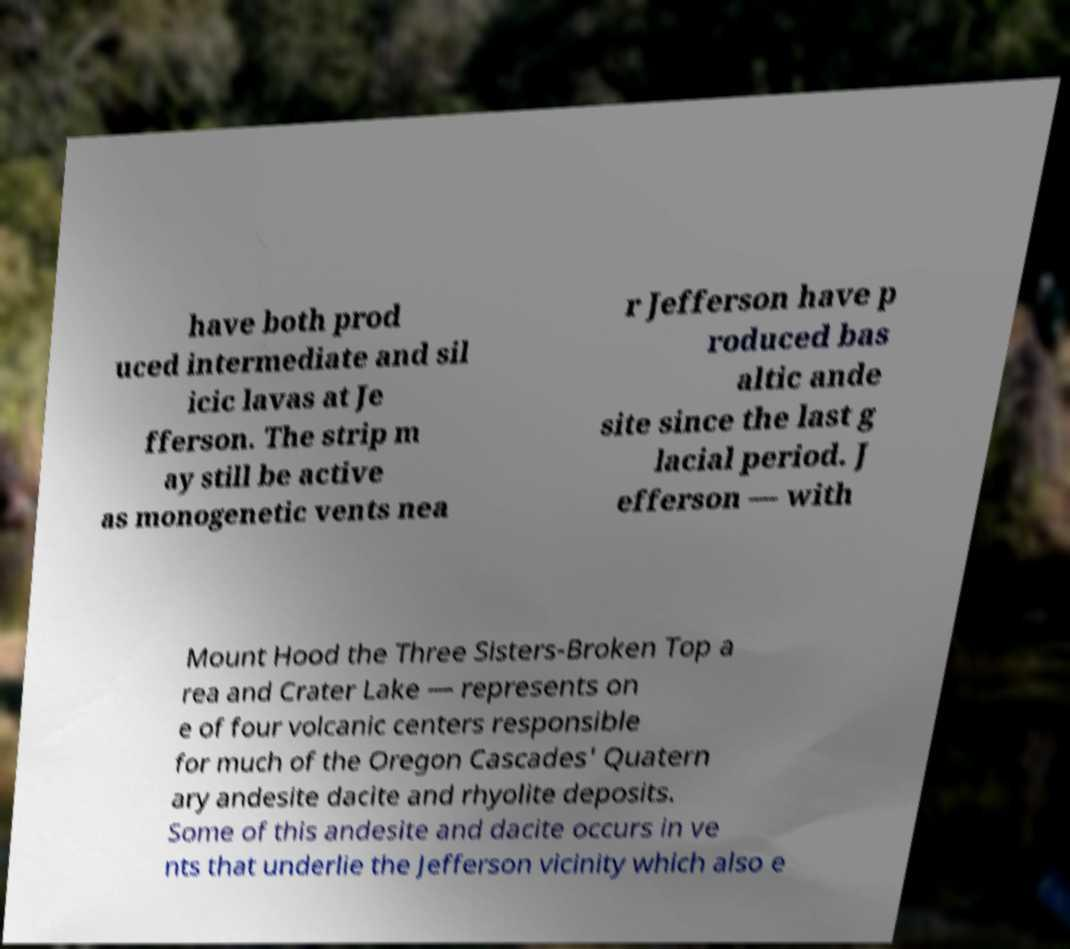Please identify and transcribe the text found in this image. have both prod uced intermediate and sil icic lavas at Je fferson. The strip m ay still be active as monogenetic vents nea r Jefferson have p roduced bas altic ande site since the last g lacial period. J efferson — with Mount Hood the Three Sisters-Broken Top a rea and Crater Lake — represents on e of four volcanic centers responsible for much of the Oregon Cascades' Quatern ary andesite dacite and rhyolite deposits. Some of this andesite and dacite occurs in ve nts that underlie the Jefferson vicinity which also e 